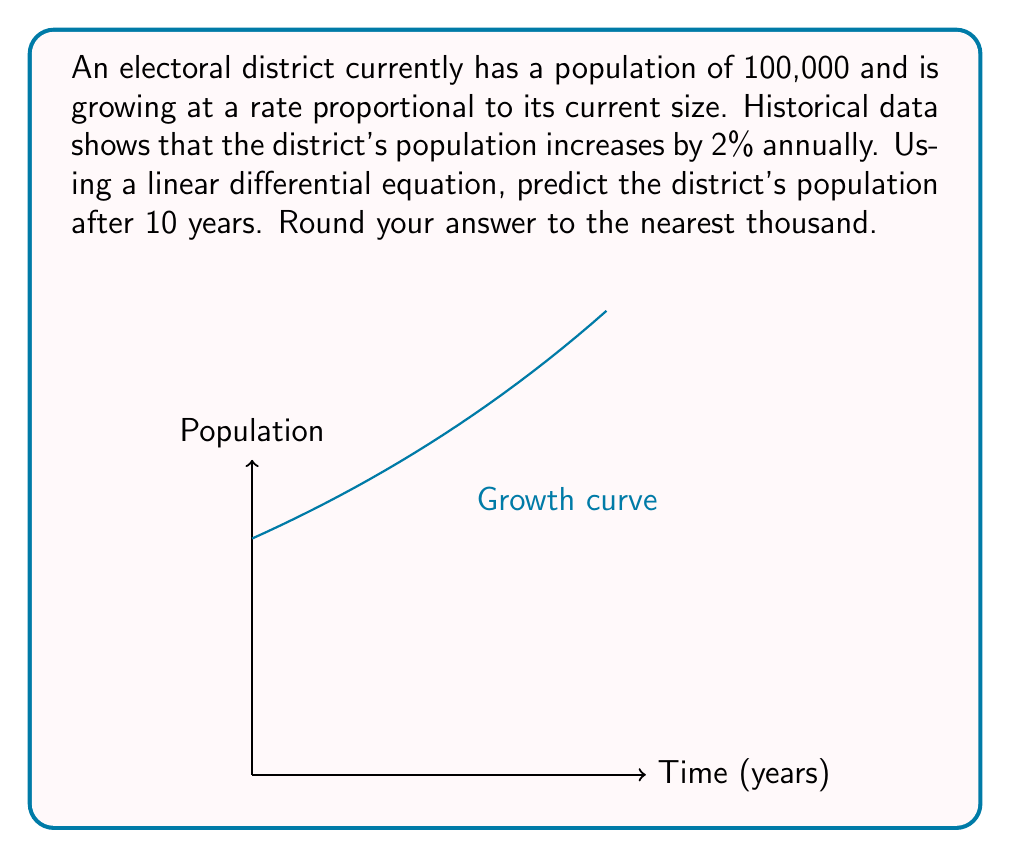Give your solution to this math problem. Let's approach this step-by-step:

1) Let $P(t)$ be the population at time $t$ (in years).

2) The rate of change of population is proportional to the current population:

   $$\frac{dP}{dt} = kP$$

   where $k$ is the growth rate constant.

3) We're told the population grows by 2% annually. This means:

   $$k = 0.02$$

4) Our differential equation is now:

   $$\frac{dP}{dt} = 0.02P$$

5) This is a separable equation. Rearranging:

   $$\frac{dP}{P} = 0.02dt$$

6) Integrating both sides:

   $$\int \frac{dP}{P} = \int 0.02dt$$
   $$\ln|P| = 0.02t + C$$

7) Solving for $P$:

   $$P = e^{0.02t + C} = e^C \cdot e^{0.02t}$$

8) Let $A = e^C$. Then:

   $$P = A \cdot e^{0.02t}$$

9) Using the initial condition $P(0) = 100,000$:

   $$100,000 = A \cdot e^0 = A$$

10) Therefore, our solution is:

    $$P(t) = 100,000 \cdot e^{0.02t}$$

11) To find the population after 10 years, we calculate $P(10)$:

    $$P(10) = 100,000 \cdot e^{0.02 \cdot 10} = 100,000 \cdot e^{0.2} \approx 122,140$$

12) Rounding to the nearest thousand:

    $$P(10) \approx 122,000$$
Answer: 122,000 